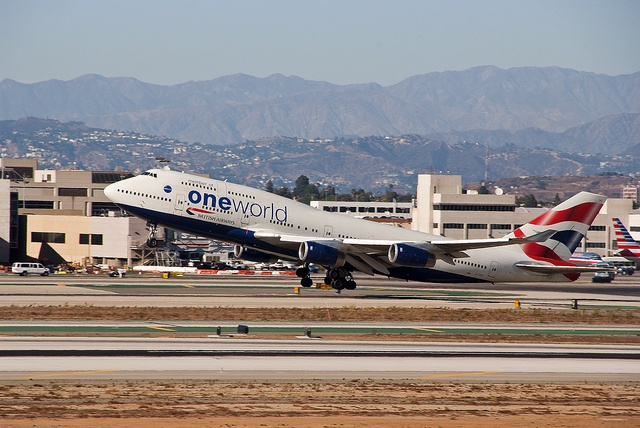Describe the objects in this image and their specific colors. I can see airplane in darkgray, black, lightgray, and gray tones, airplane in darkgray, brown, black, and lightgray tones, truck in darkgray, black, lightgray, and gray tones, and car in darkgray, black, lightgray, and gray tones in this image. 